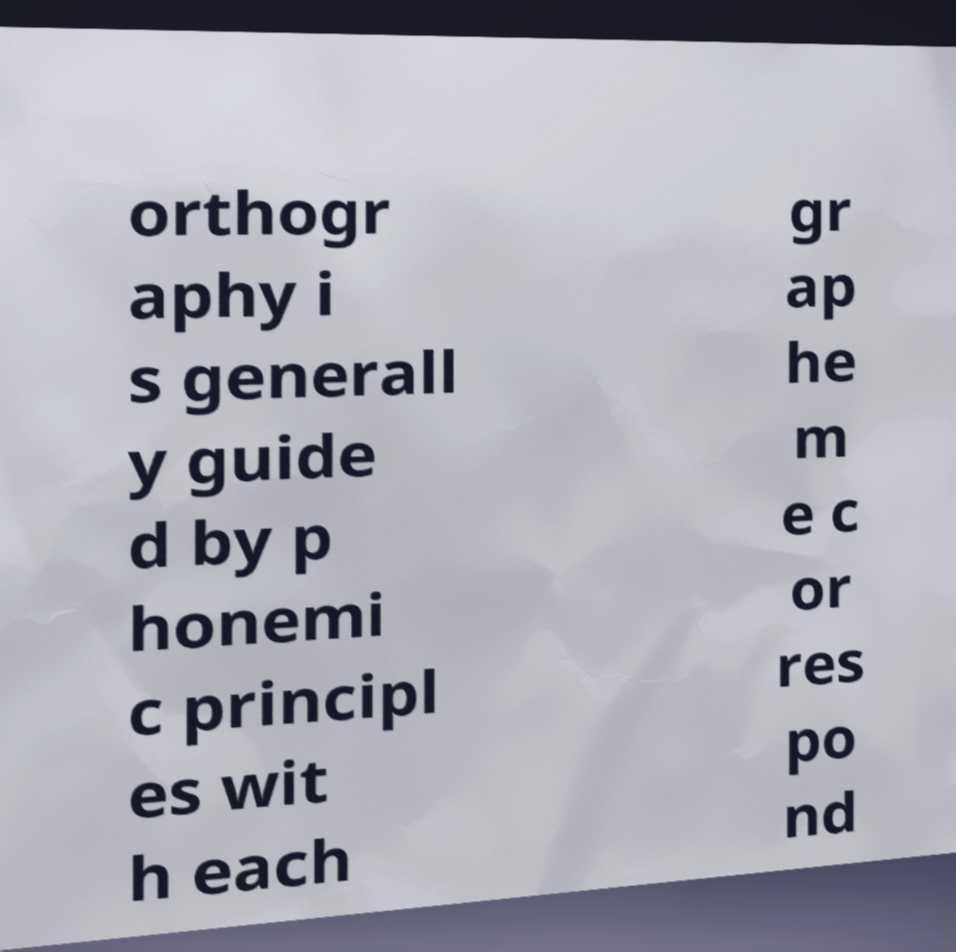I need the written content from this picture converted into text. Can you do that? orthogr aphy i s generall y guide d by p honemi c principl es wit h each gr ap he m e c or res po nd 